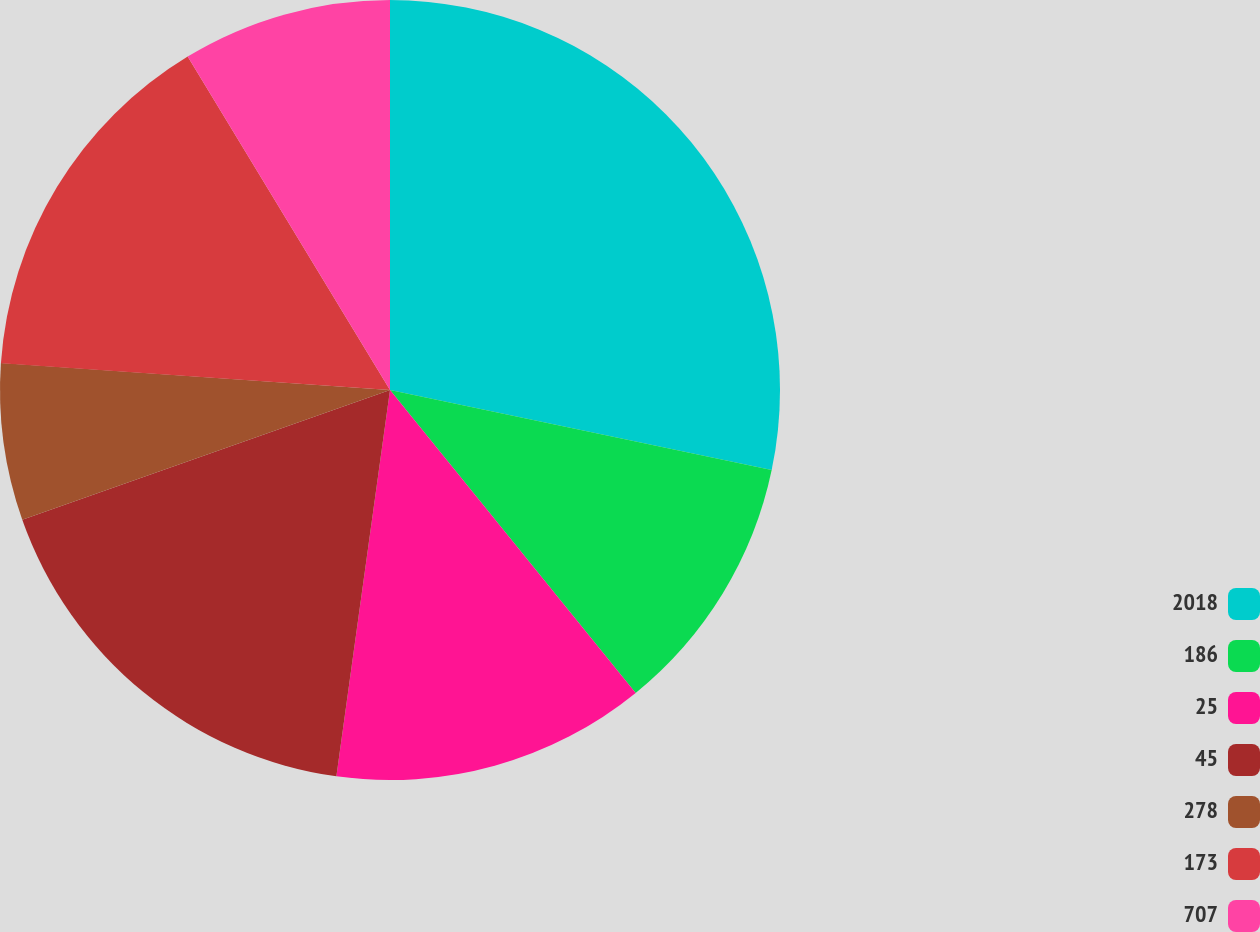Convert chart. <chart><loc_0><loc_0><loc_500><loc_500><pie_chart><fcel>2018<fcel>186<fcel>25<fcel>45<fcel>278<fcel>173<fcel>707<nl><fcel>28.29%<fcel>10.86%<fcel>13.04%<fcel>17.4%<fcel>6.5%<fcel>15.22%<fcel>8.68%<nl></chart> 